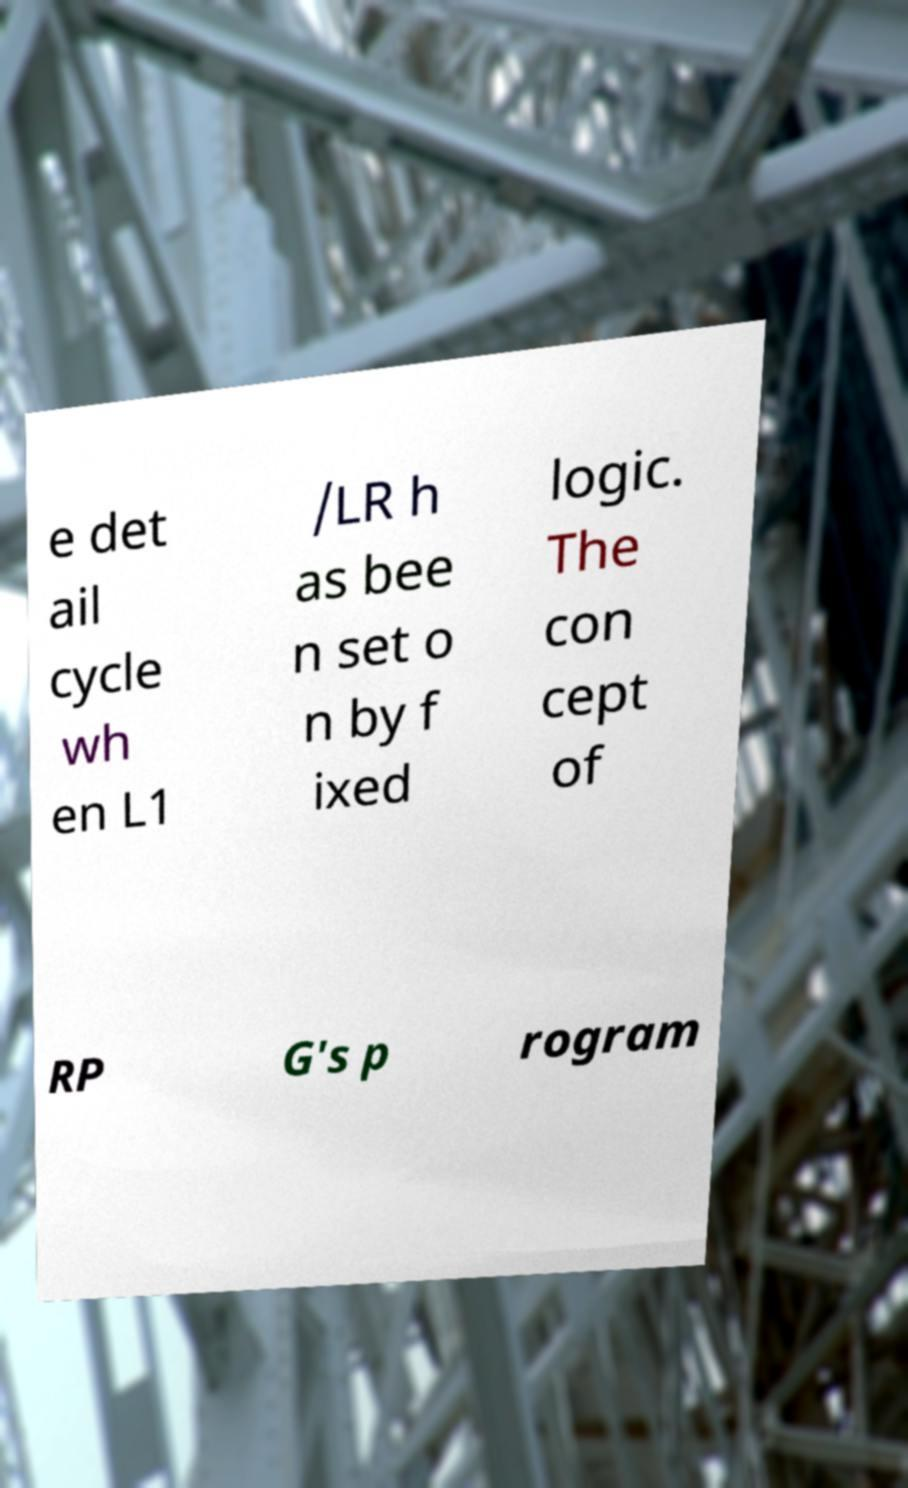I need the written content from this picture converted into text. Can you do that? e det ail cycle wh en L1 /LR h as bee n set o n by f ixed logic. The con cept of RP G's p rogram 